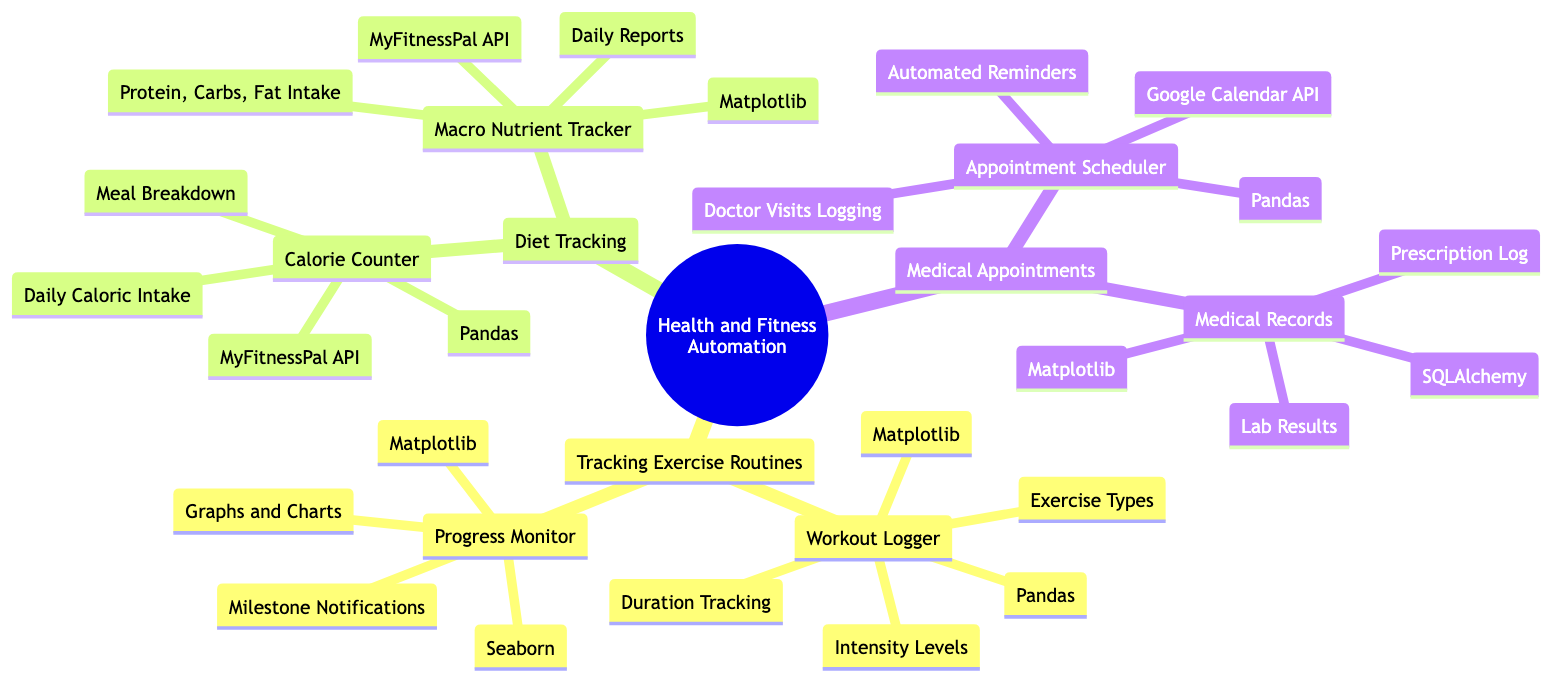What are the two main categories under Health and Fitness Automation? The diagram shows three main categories, and by inspecting the first level beneath the root node, we can identify them as "Tracking Exercise Routines," "Diet Tracking," and "Medical Appointments."
Answer: Tracking Exercise Routines, Diet Tracking, Medical Appointments What is a featured library used in the Workout Logger? Looking at the "Workout Logger" node under "Tracking Exercise Routines," we can see the associated libraries listed beneath it. One of them is "Pandas."
Answer: Pandas How many features does the Progress Monitor have? By examining the "Progress Monitor" node, we can count the number of listed features beneath it. They are "Graphs and Charts" and "Milestone Notifications," which totals to two features.
Answer: 2 What kind of tracking does the Macro Nutrient Tracker perform? The "Macro Nutrient Tracker" node lists its features, which include "Protein, Carbs, Fat Intake" and "Daily Reports," indicating its function in tracking macronutrients.
Answer: Protein, Carbs, Fat Intake Which library is used for the Medical Records component? In the "Medical Records" section under "Medical Appointments," the diagram shows "SQLAlchemy" as one of the libraries used, directly answering the question.
Answer: SQLAlchemy How many components does the Diet Tracking category have? The Diet Tracking category is broken down into two components according to the diagram: "Calorie Counter" and "Macro Nutrient Tracker." Therefore, the total number of components is two.
Answer: 2 What feature does the Appointment Scheduler provide? Looking into the "Appointment Scheduler" component, it lists "Automated Reminders" as one of its features, which directly answers the question about what features it offers.
Answer: Automated Reminders What is the purpose of the Progress Monitor? We can determine the purpose of the Progress Monitor based on its features: "Graphs and Charts" and "Milestone Notifications," which indicate that it serves to monitor and visualize fitness progress.
Answer: Monitoring fitness progress Which API is used in the Calorie Counter? By examining the "Calorie Counter" component, we find that it utilizes the "MyFitnessPal API," directly answering the question regarding which API is associated with it.
Answer: MyFitnessPal API 